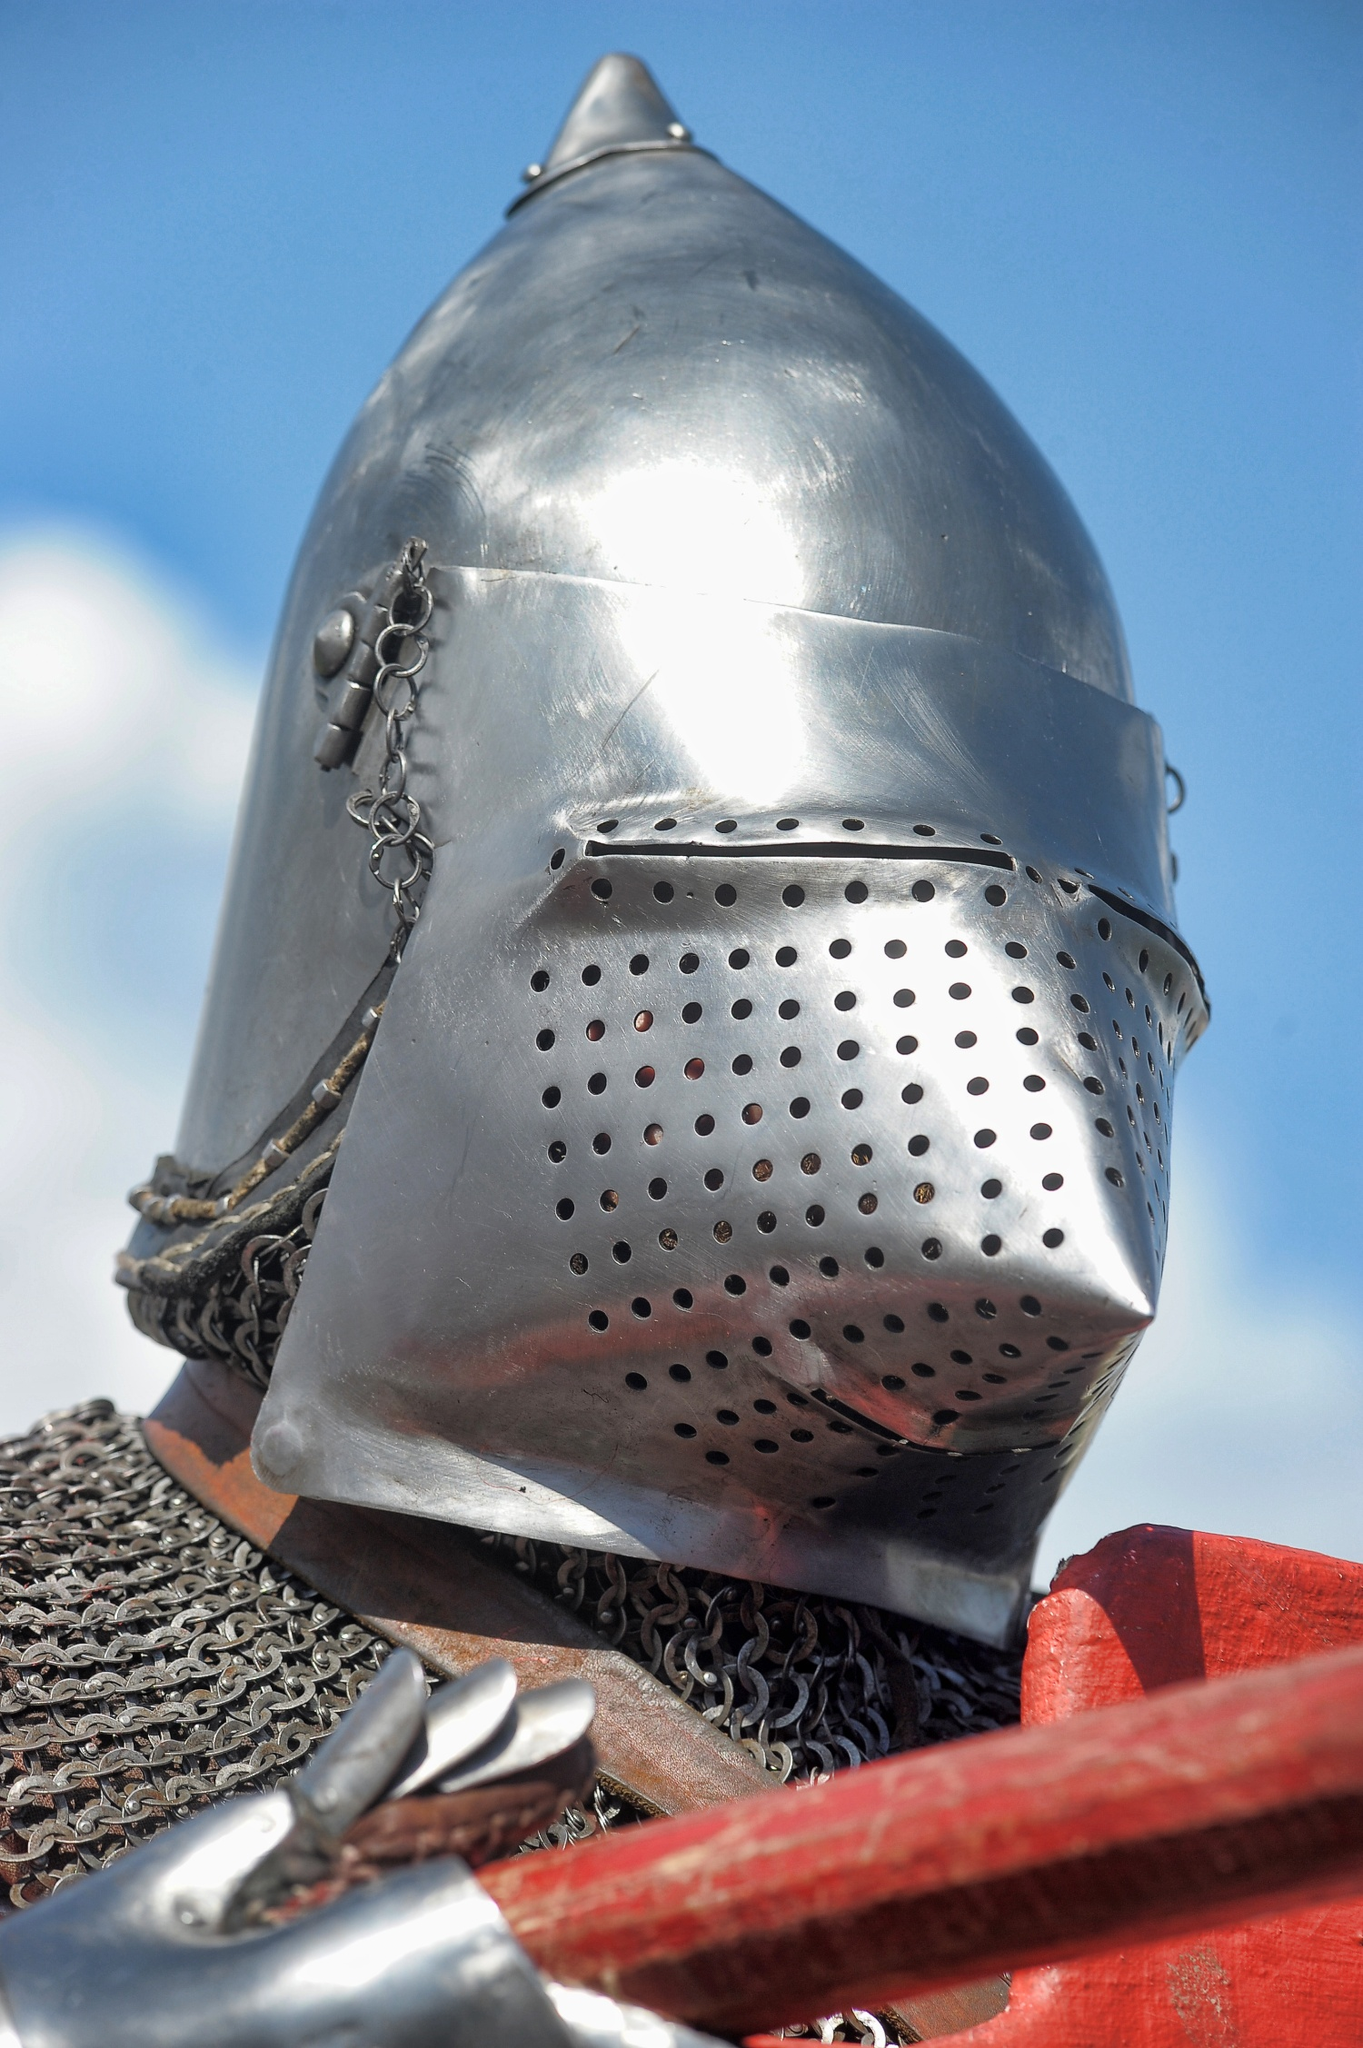What could be the significance of the way this helmet is displayed? The helmet is carefully mounted on a red stand, indicative of a display meant for observation rather than use in battle. It could be a part of a museum exhibit, a cultural event, or a renaissance fair where artifacts from the medieval period are showcased to educate and engage the public about historical warfare and craftsmanship. 